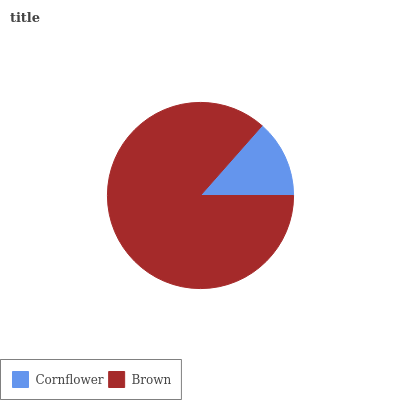Is Cornflower the minimum?
Answer yes or no. Yes. Is Brown the maximum?
Answer yes or no. Yes. Is Brown the minimum?
Answer yes or no. No. Is Brown greater than Cornflower?
Answer yes or no. Yes. Is Cornflower less than Brown?
Answer yes or no. Yes. Is Cornflower greater than Brown?
Answer yes or no. No. Is Brown less than Cornflower?
Answer yes or no. No. Is Brown the high median?
Answer yes or no. Yes. Is Cornflower the low median?
Answer yes or no. Yes. Is Cornflower the high median?
Answer yes or no. No. Is Brown the low median?
Answer yes or no. No. 